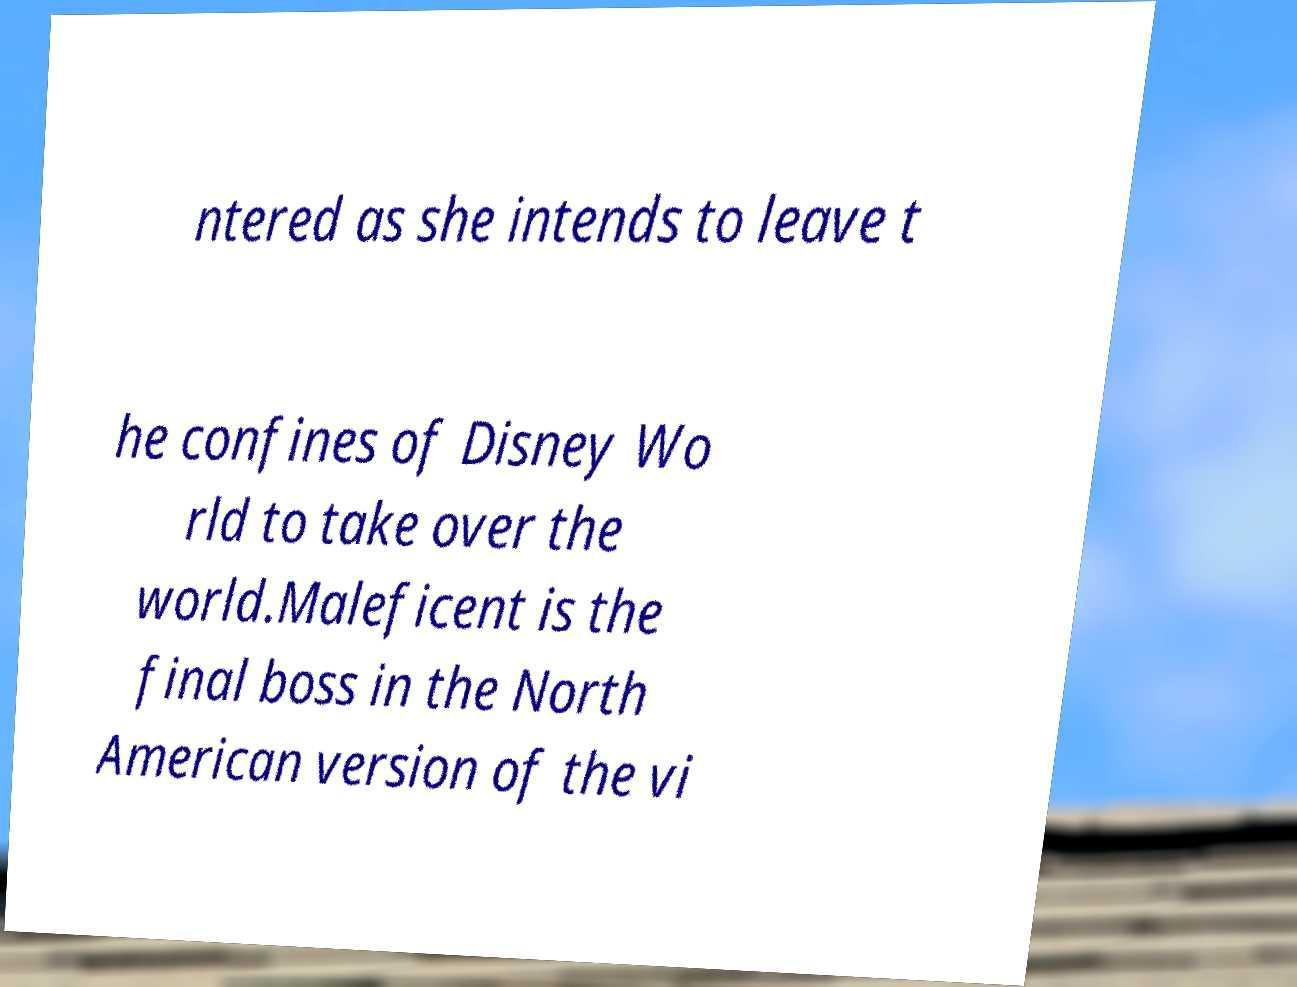What messages or text are displayed in this image? I need them in a readable, typed format. ntered as she intends to leave t he confines of Disney Wo rld to take over the world.Maleficent is the final boss in the North American version of the vi 